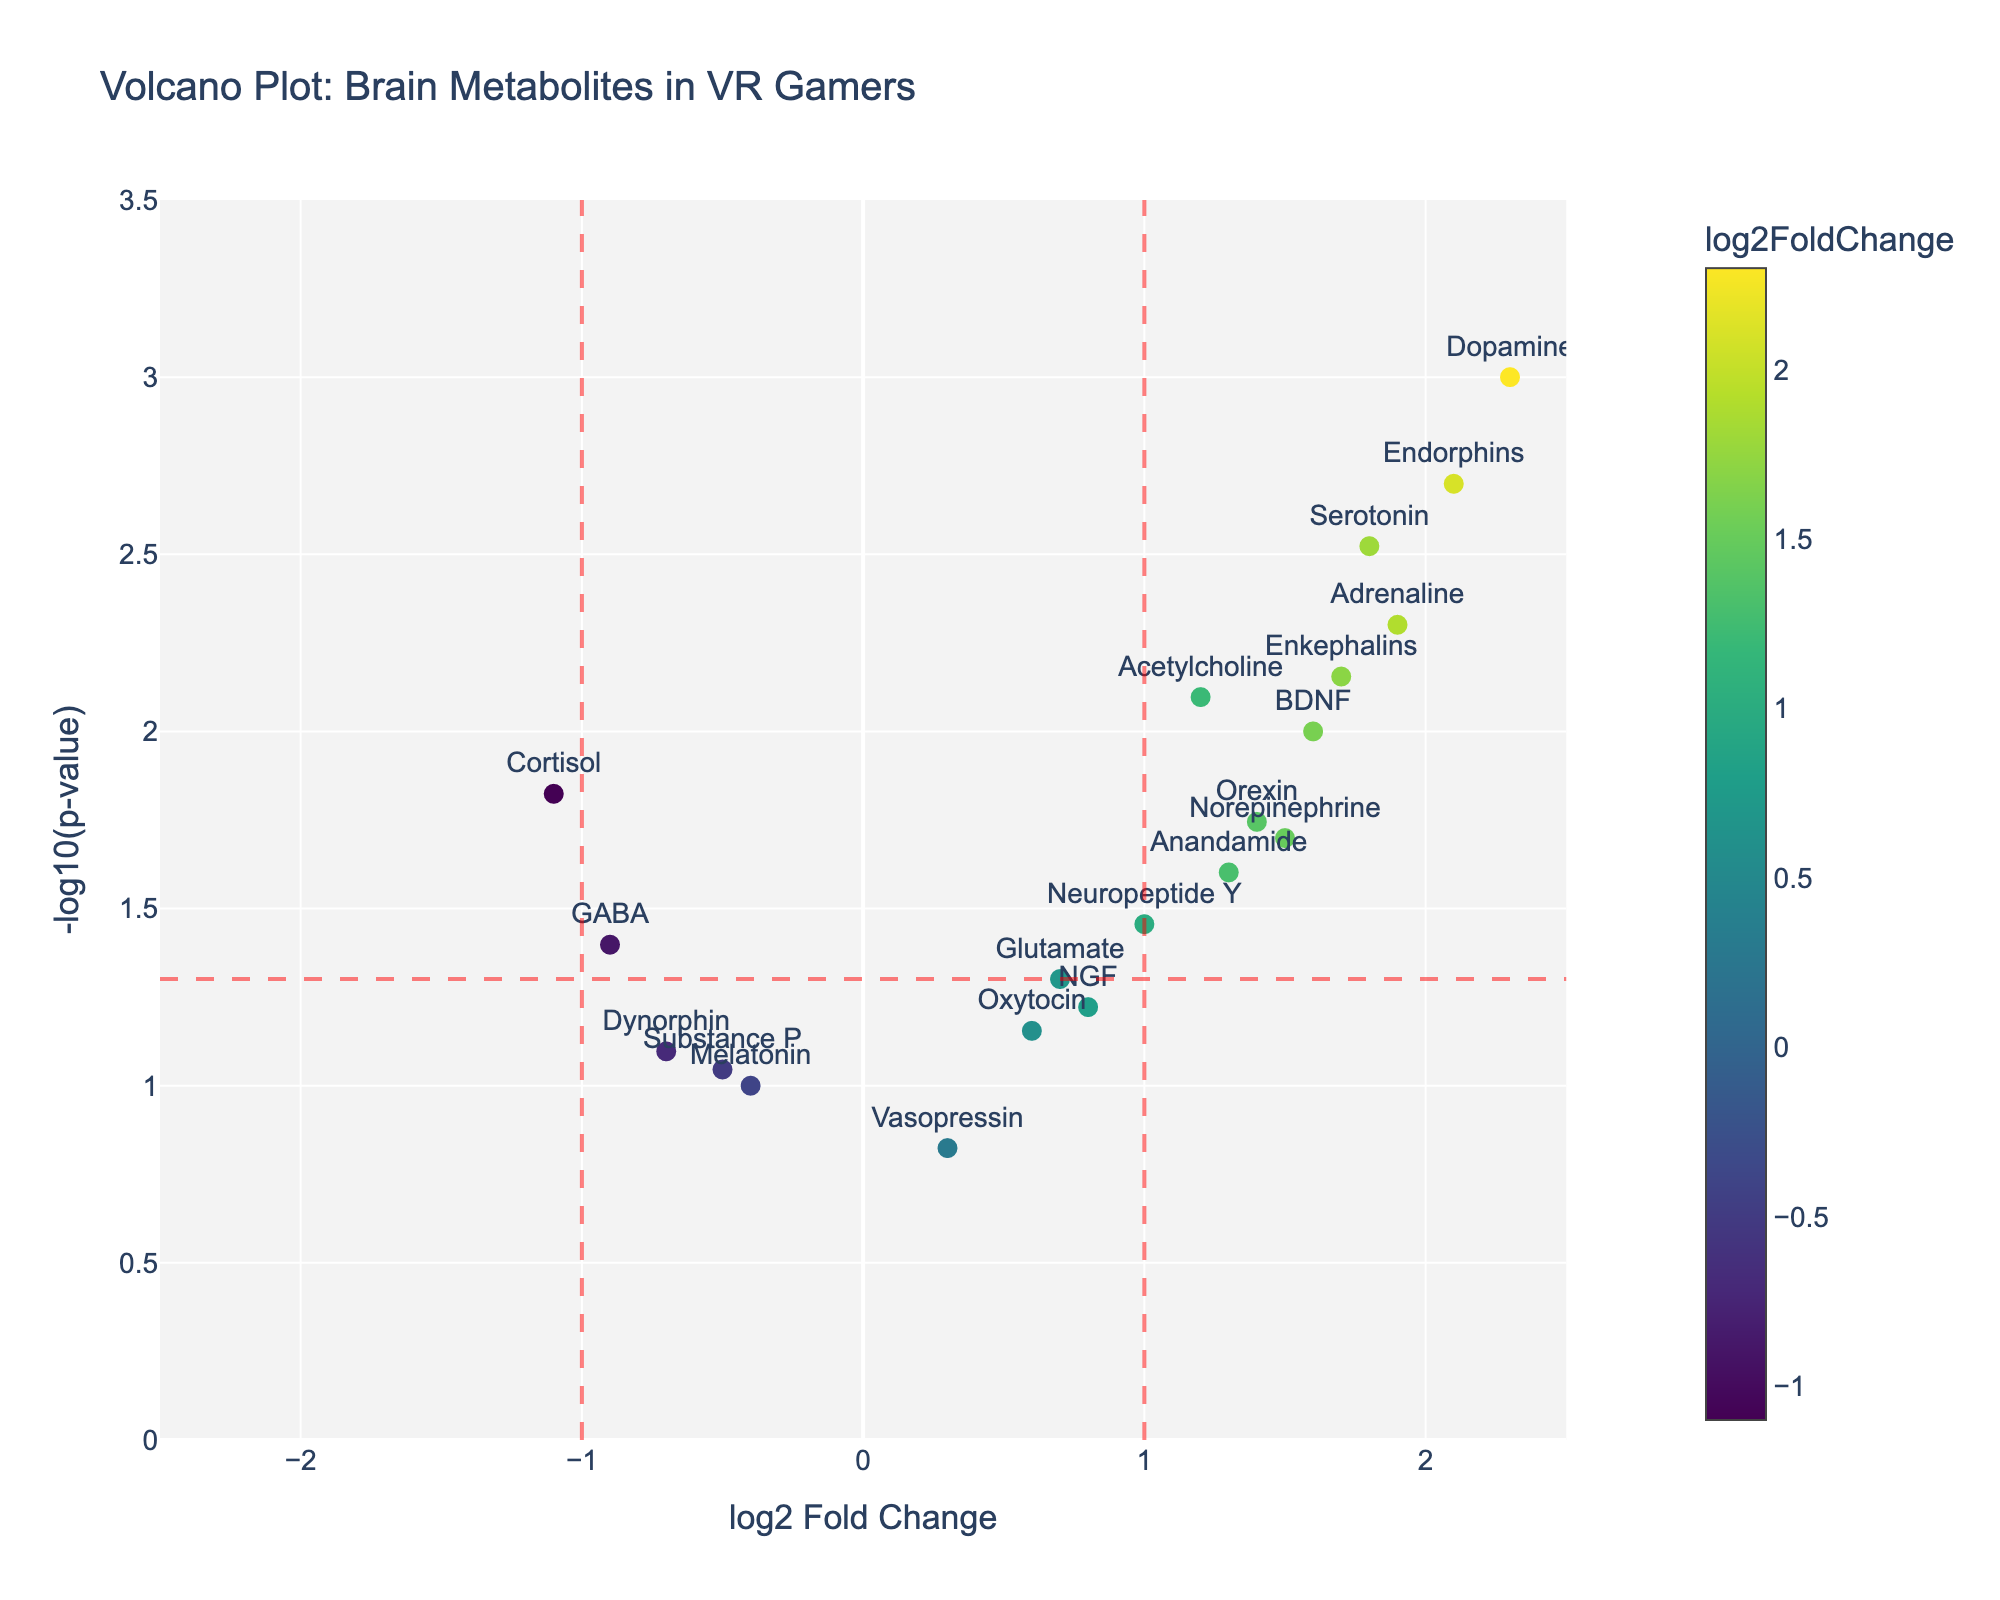Which molecule has the highest -log10(p-value)? To identify the molecule with the highest -log10(p-value), look for the point that is placed the highest on the y-axis. The molecule associated with this point is Dopamine because it has the highest y-axis value.
Answer: Dopamine Which molecules have a log2 Fold Change greater than 2? To find molecules with a log2 Fold Change greater than 2, check the x-axis values. Dopamine (2.3) and Endorphins (2.1) have log2 Fold Change values greater than 2.
Answer: Dopamine, Endorphins What is the approximate p-value for Neurotensin? The p-value can be inferred from the -log10(p-value). For Neurotensin, the y-axis value is around 1.5. The p-value can be calculated as \( p = 10^{-y} \), so \( p = 10^{-1.5} ≈ 0.03 \).
Answer: 0.03 Which molecule has the lowest log2 Fold Change? To find the molecule with the lowest log2 Fold Change, look for the point furthest to the left on the x-axis. The molecule with the lowest log2 Fold Change is Cortisol (-1.1).
Answer: Cortisol How many molecules have a p-value less than 0.05? To determine this, find the molecules above the horizontal threshold line at y = -log10(0.05). Count the points above this line. There are 9 molecules (Dopamine, Endorphins, Serotonin, Acetylcholine, Adrenaline, BDNF, Enkephalins, Orexin, Norepinephrine) with p-values less than 0.05.
Answer: 9 What is the log2 Fold Change for Enkephalins, and is it above or below 1? Locate Enkephalins on the plot by its label, check its x-axis value, which is its log2 Fold Change. Enkephalins has a log2 Fold Change of 1.7, which is above 1.
Answer: 1.7, above 1 Between Adrenaline and GABA, which molecule has a higher -log10(p-value)? Compare the y-axis positions of Adrenaline and GABA. Adrenaline is higher on the y-axis, indicating a higher -log10(p-value).
Answer: Adrenaline Which molecules have both a log2 Fold Change greater than 1 and a p-value less than 0.05? Identify the molecules with both x-axis values greater than 1 and y-axis values above the horizontal threshold line (-log10(0.05)). The molecules are Dopamine, Endorphins, Serotonin, Adrenaline, BDNF, Enkephalins, Orexin, and Acetylcholine.
Answer: Dopamine, Endorphins, Serotonin, Adrenaline, BDNF, Enkephalins, Orexin, Acetylcholine How many molecules have a log2 Fold Change between -1 and 1, inclusive? Count the points whose x-axis values are between -1 and 1, including the endpoints. There are 9 molecules (Norepinephrine, GABA, Glutamate, Oxytocin, Melatonin, NGF, Substance P, Vasopressin, Neuropeptide Y) within this range.
Answer: 9 What is the approximate -log10(p-value) for Acetylcholine? Find the point labeled Acetylcholine and read its y-axis value. The y-axis value (approximately -log10(p-value)) for Acetylcholine is around 2.1.
Answer: 2.1 